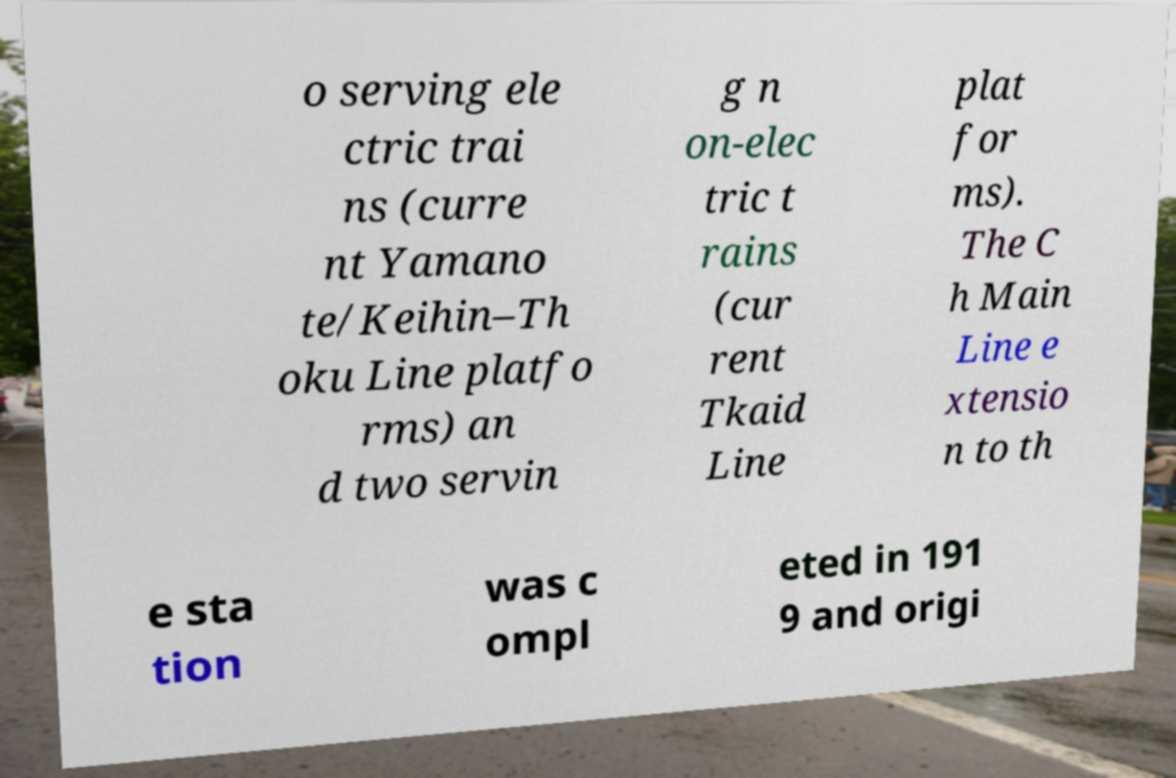What messages or text are displayed in this image? I need them in a readable, typed format. o serving ele ctric trai ns (curre nt Yamano te/Keihin–Th oku Line platfo rms) an d two servin g n on-elec tric t rains (cur rent Tkaid Line plat for ms). The C h Main Line e xtensio n to th e sta tion was c ompl eted in 191 9 and origi 